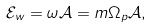Convert formula to latex. <formula><loc_0><loc_0><loc_500><loc_500>\mathcal { E } _ { w } = \omega \mathcal { A } = m \Omega _ { p } \mathcal { A } ,</formula> 